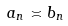<formula> <loc_0><loc_0><loc_500><loc_500>a _ { n } \asymp b _ { n }</formula> 